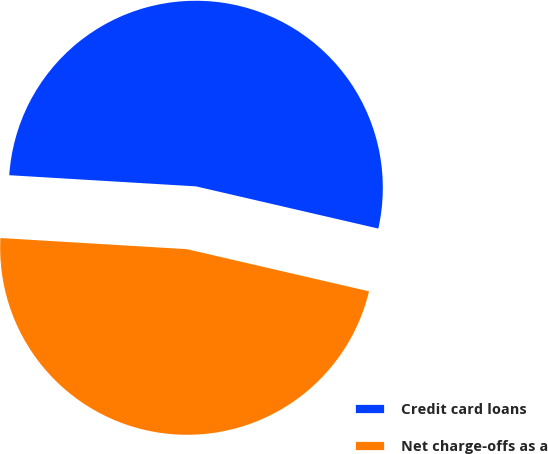<chart> <loc_0><loc_0><loc_500><loc_500><pie_chart><fcel>Credit card loans<fcel>Net charge-offs as a<nl><fcel>52.67%<fcel>47.33%<nl></chart> 